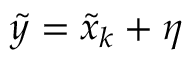Convert formula to latex. <formula><loc_0><loc_0><loc_500><loc_500>\tilde { y } = \tilde { x } _ { k } + \eta</formula> 